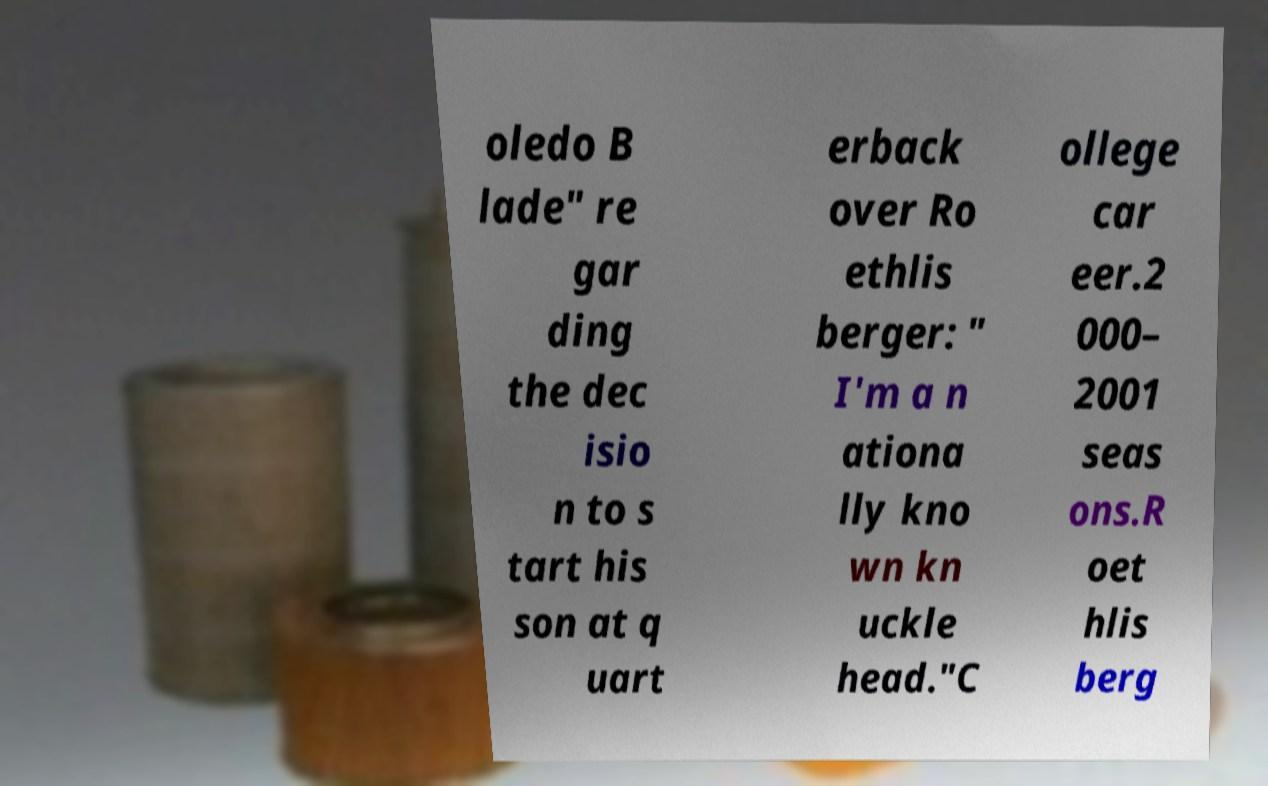Can you read and provide the text displayed in the image?This photo seems to have some interesting text. Can you extract and type it out for me? oledo B lade" re gar ding the dec isio n to s tart his son at q uart erback over Ro ethlis berger: " I'm a n ationa lly kno wn kn uckle head."C ollege car eer.2 000– 2001 seas ons.R oet hlis berg 